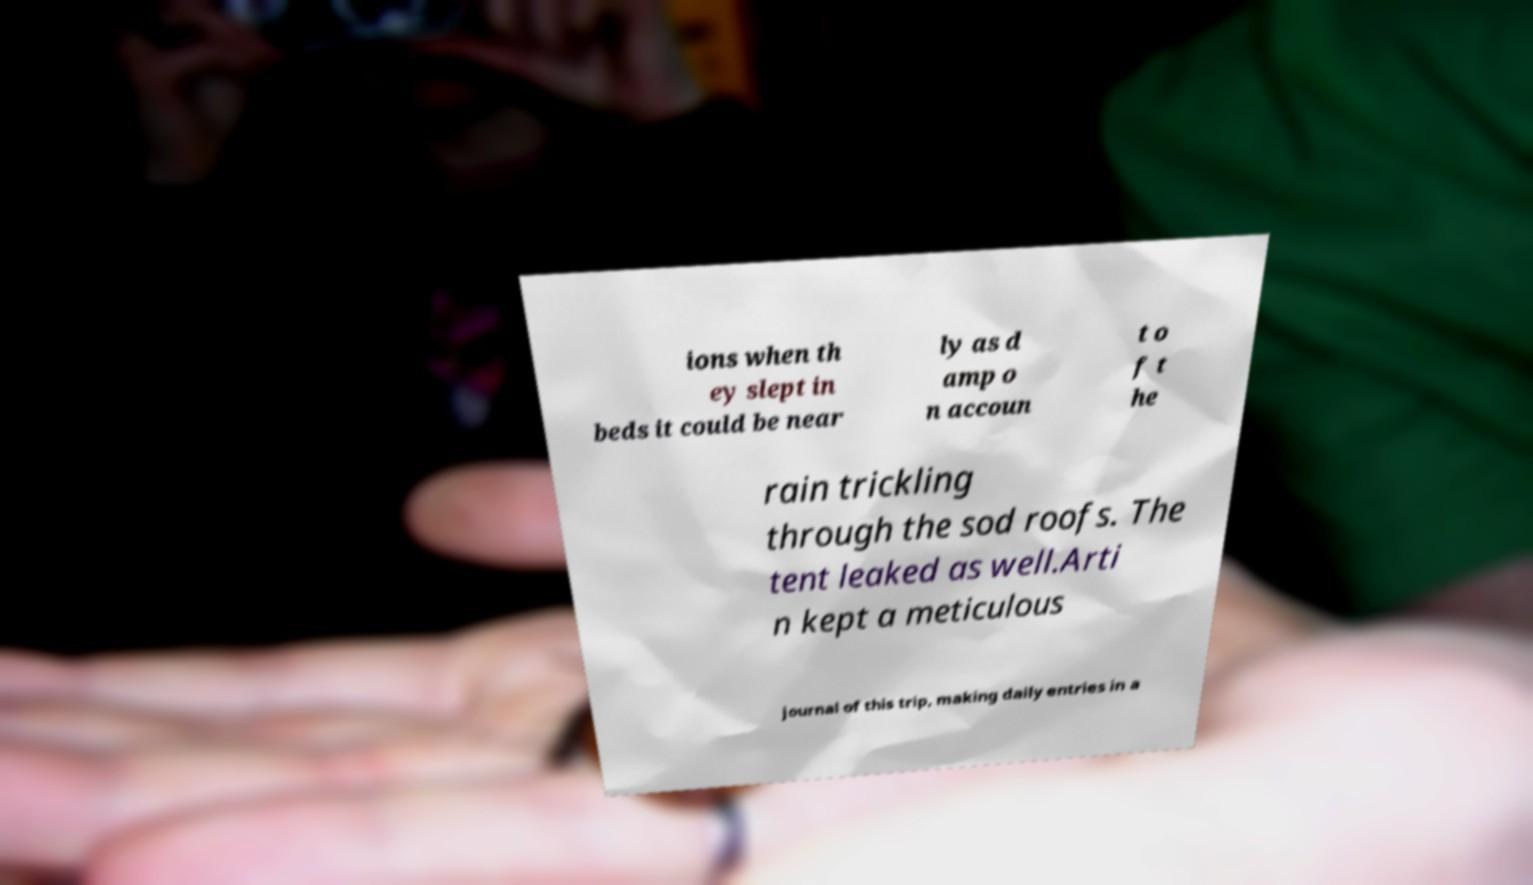Could you extract and type out the text from this image? ions when th ey slept in beds it could be near ly as d amp o n accoun t o f t he rain trickling through the sod roofs. The tent leaked as well.Arti n kept a meticulous journal of this trip, making daily entries in a 